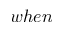Convert formula to latex. <formula><loc_0><loc_0><loc_500><loc_500>w h e n</formula> 